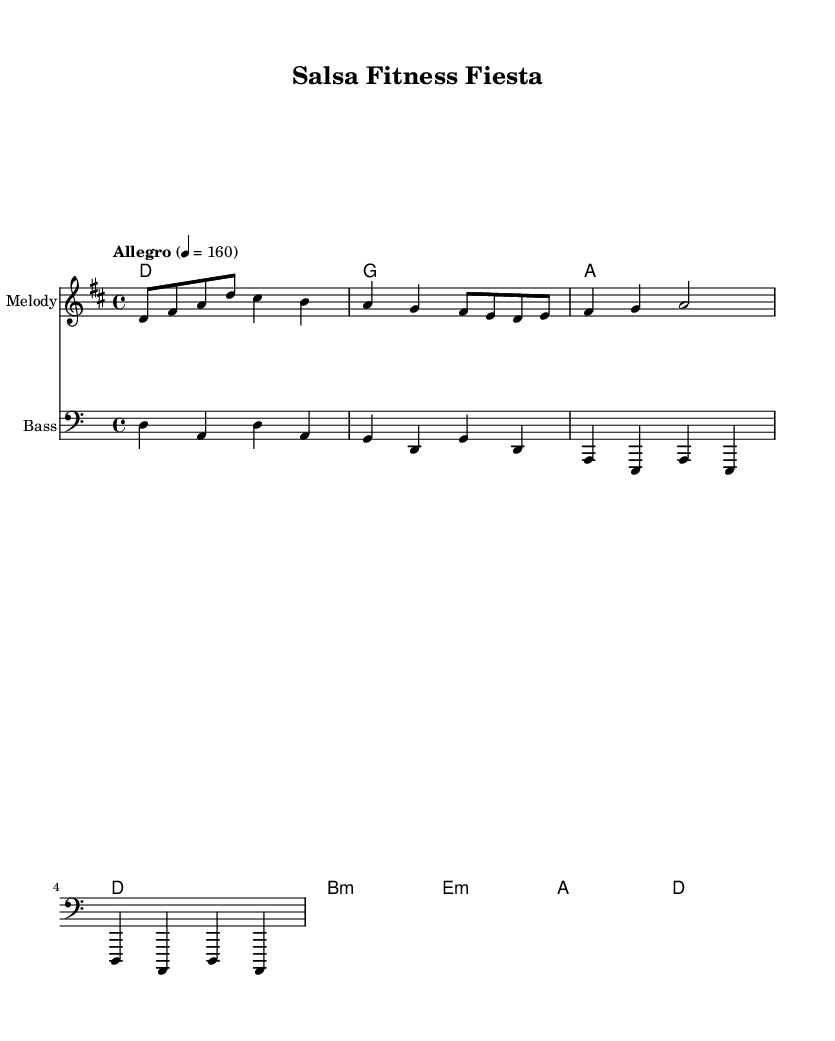What is the key signature of this music? The key signature is two sharps, which indicates the key of D major. The presence of F# and C# in the scale confirms this.
Answer: D major What is the time signature of this music? The time signature is indicated at the beginning of the sheet music as 4/4, meaning there are four beats per measure.
Answer: 4/4 What is the tempo marking for this piece? The tempo is marked as "Allegro" with a metronome marking of 160 beats per minute. This suggests a lively and fast-paced rhythm.
Answer: Allegro, 160 How many measures are in the melody section? Counting the bar lines in the melody, there are a total of four measures indicated.
Answer: 4 What is the first chord of the harmony section? The first chord shown in the harmony section is D major, indicated by the 'd' at the beginning.
Answer: D What kind of rhythmic pattern is primarily used in the melody? The melody consists mainly of eighth notes and quarter notes, giving it a dynamic and syncopated rhythmic feel typical of salsa music.
Answer: Eighth and quarter notes What is the mood conveyed by the lyrics? The lyrics express a feeling of excitement and movement, as they encourage the listener to "move your body" and "feel the beat," which is characteristic of salsa music.
Answer: Excitement 